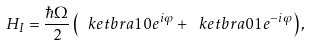<formula> <loc_0><loc_0><loc_500><loc_500>H _ { I } = \frac { \hbar { \Omega } } { 2 } \left ( \ k e t b r a { 1 } { 0 } e ^ { i \varphi } + \ k e t b r a { 0 } { 1 } e ^ { - i \varphi } \right ) ,</formula> 